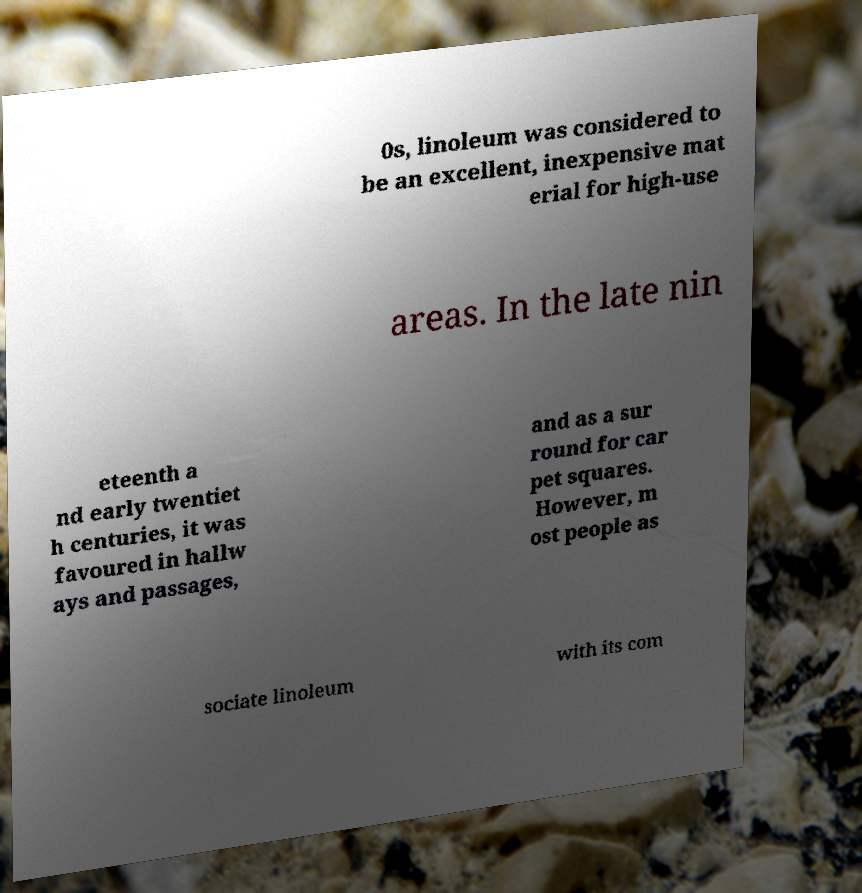Could you extract and type out the text from this image? 0s, linoleum was considered to be an excellent, inexpensive mat erial for high-use areas. In the late nin eteenth a nd early twentiet h centuries, it was favoured in hallw ays and passages, and as a sur round for car pet squares. However, m ost people as sociate linoleum with its com 